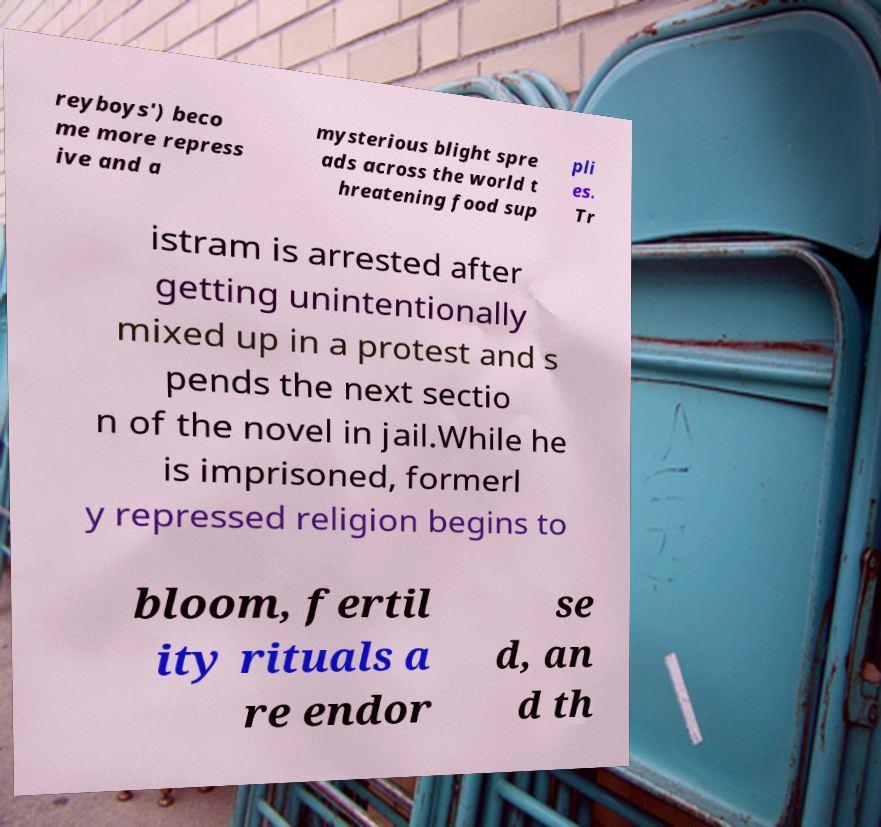There's text embedded in this image that I need extracted. Can you transcribe it verbatim? reyboys') beco me more repress ive and a mysterious blight spre ads across the world t hreatening food sup pli es. Tr istram is arrested after getting unintentionally mixed up in a protest and s pends the next sectio n of the novel in jail.While he is imprisoned, formerl y repressed religion begins to bloom, fertil ity rituals a re endor se d, an d th 